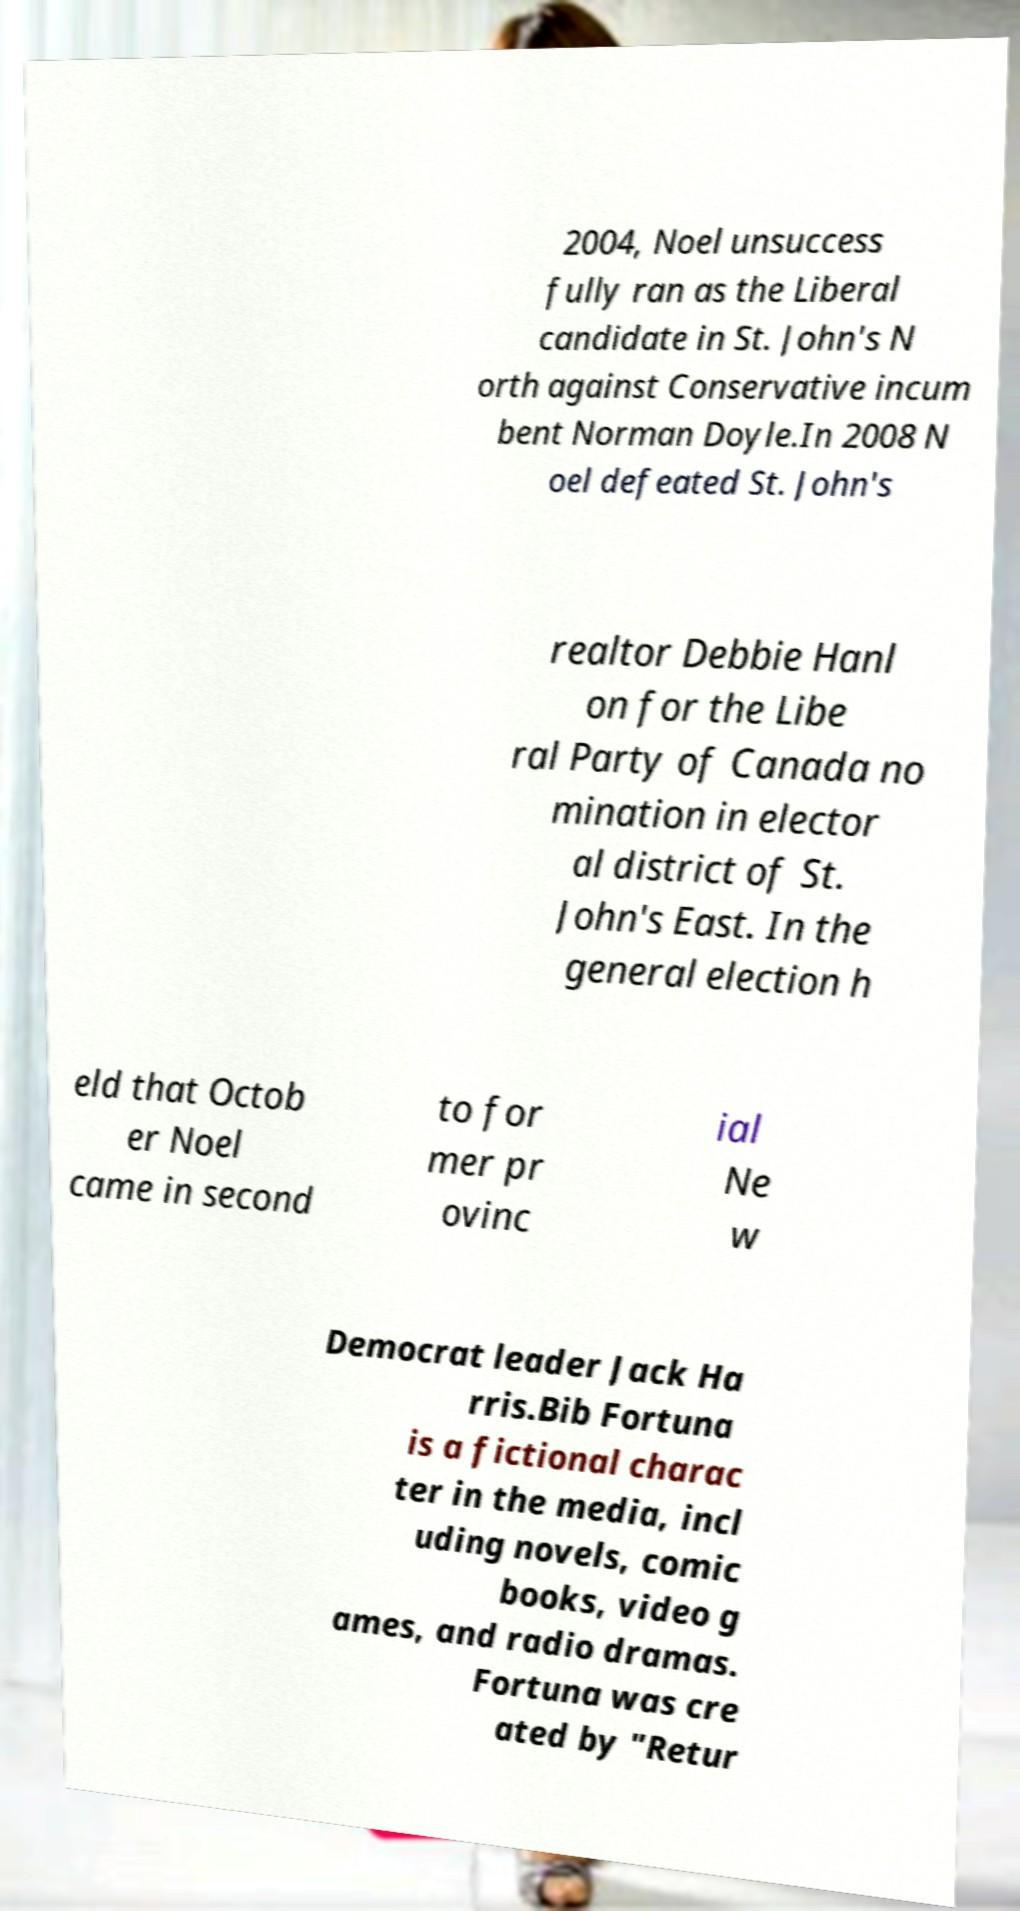There's text embedded in this image that I need extracted. Can you transcribe it verbatim? 2004, Noel unsuccess fully ran as the Liberal candidate in St. John's N orth against Conservative incum bent Norman Doyle.In 2008 N oel defeated St. John's realtor Debbie Hanl on for the Libe ral Party of Canada no mination in elector al district of St. John's East. In the general election h eld that Octob er Noel came in second to for mer pr ovinc ial Ne w Democrat leader Jack Ha rris.Bib Fortuna is a fictional charac ter in the media, incl uding novels, comic books, video g ames, and radio dramas. Fortuna was cre ated by "Retur 